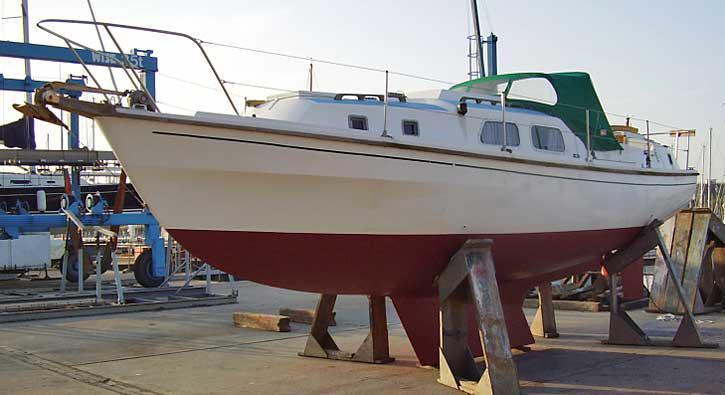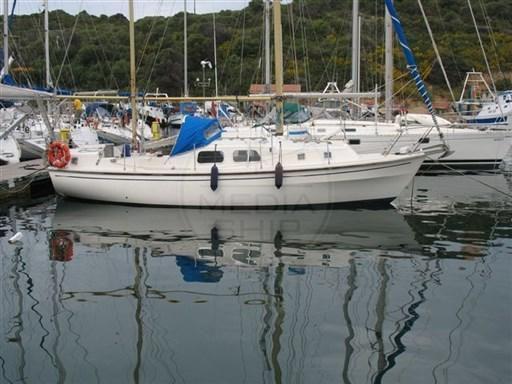The first image is the image on the left, the second image is the image on the right. For the images displayed, is the sentence "There are at least two blue sails." factually correct? Answer yes or no. No. 